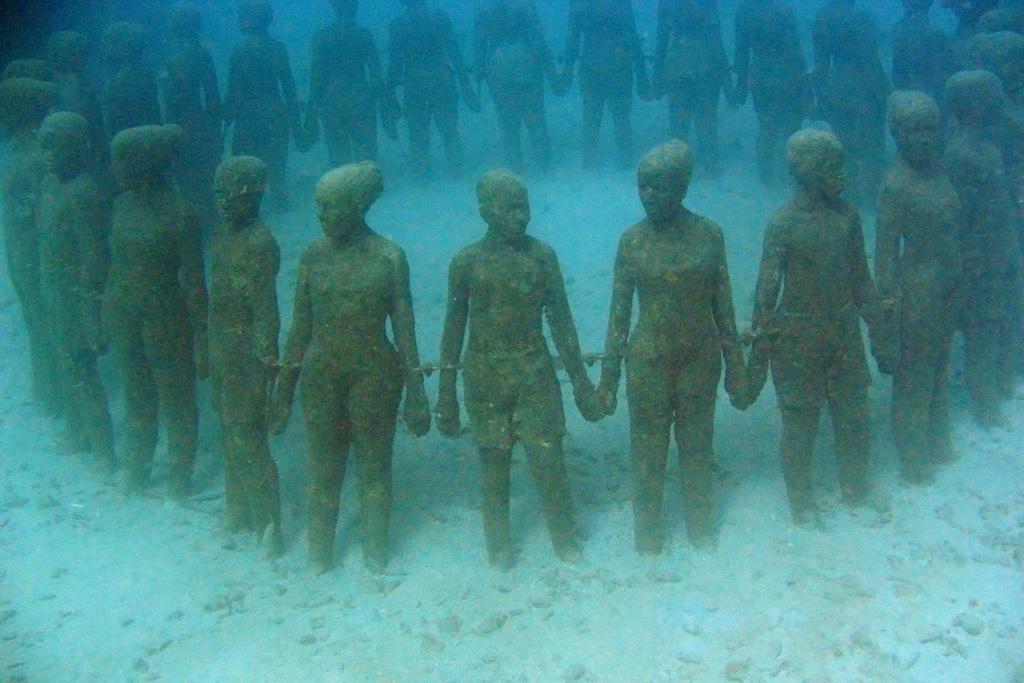Describe this image in one or two sentences. This is an image clicked inside the water. Here I can see few statues of the persons. 